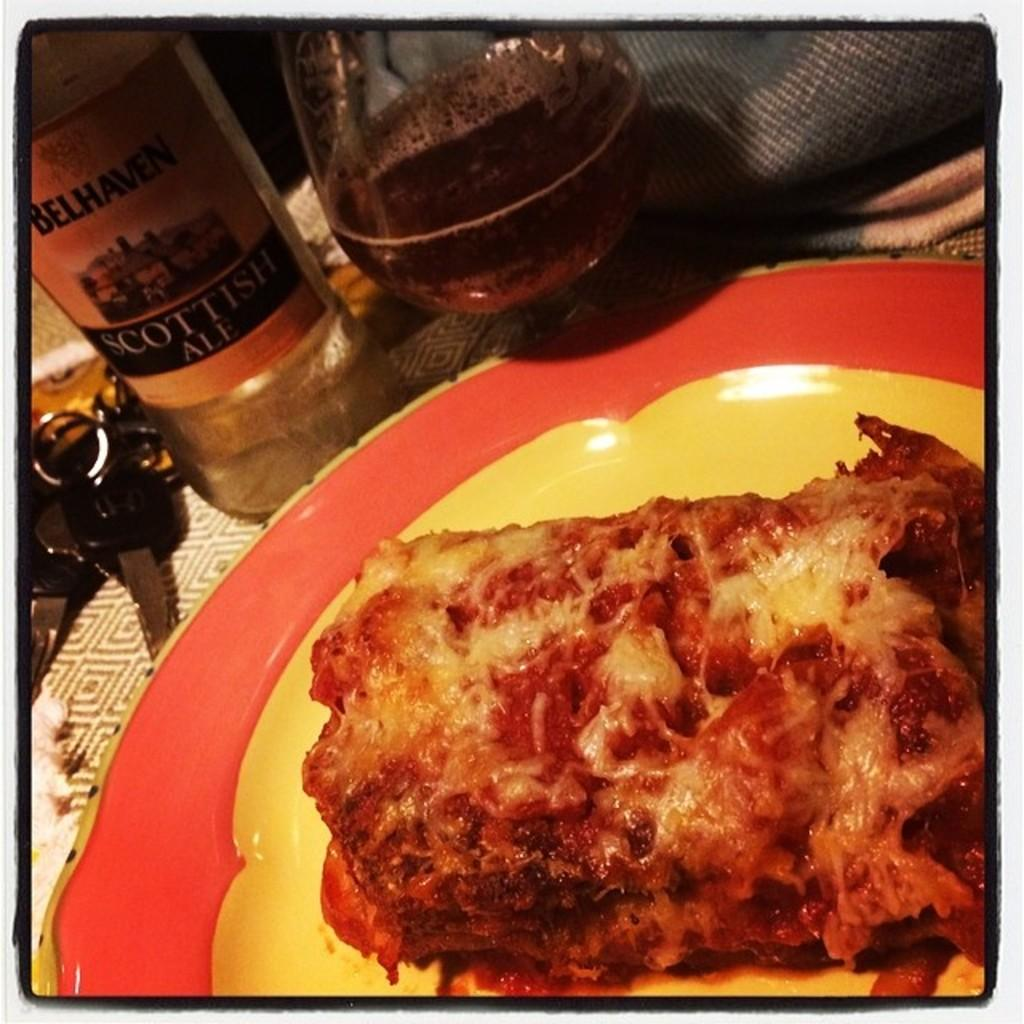<image>
Describe the image concisely. A plate with a slice of lasagna and a bottle of Scottish Ale. 